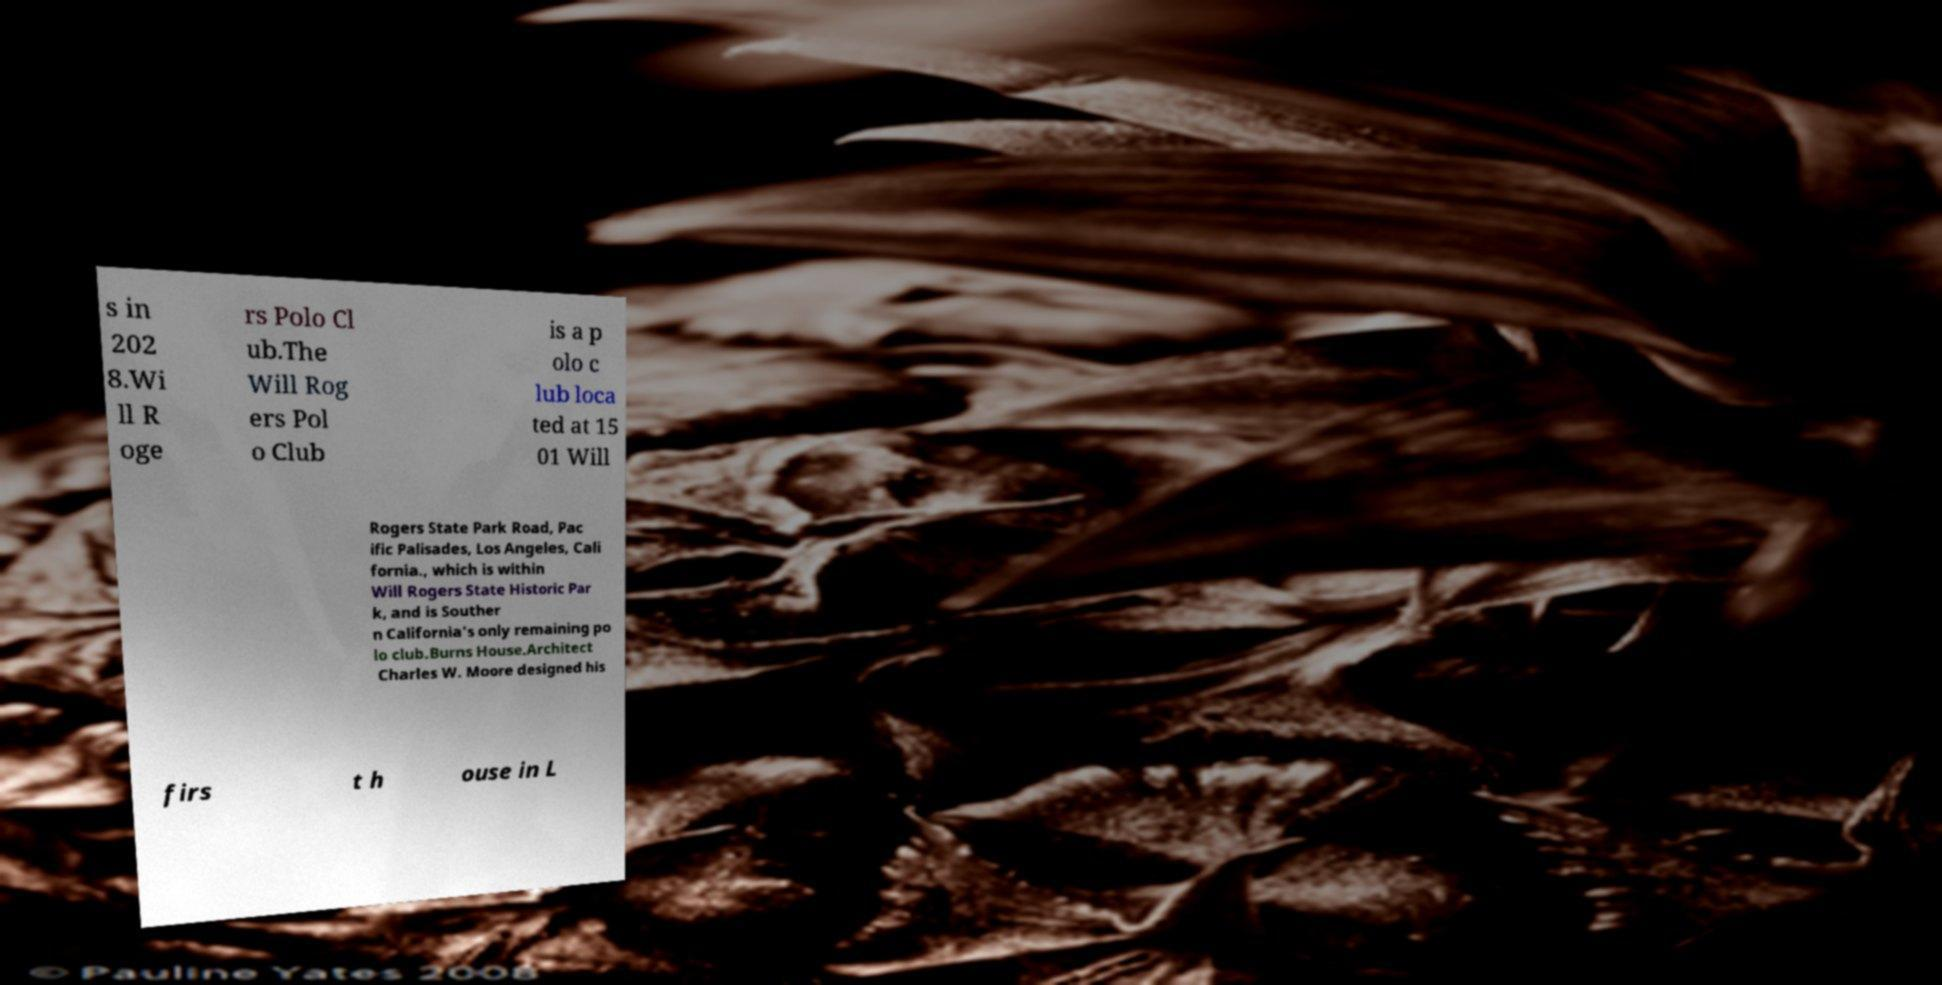Please read and relay the text visible in this image. What does it say? s in 202 8.Wi ll R oge rs Polo Cl ub.The Will Rog ers Pol o Club is a p olo c lub loca ted at 15 01 Will Rogers State Park Road, Pac ific Palisades, Los Angeles, Cali fornia., which is within Will Rogers State Historic Par k, and is Souther n California's only remaining po lo club.Burns House.Architect Charles W. Moore designed his firs t h ouse in L 